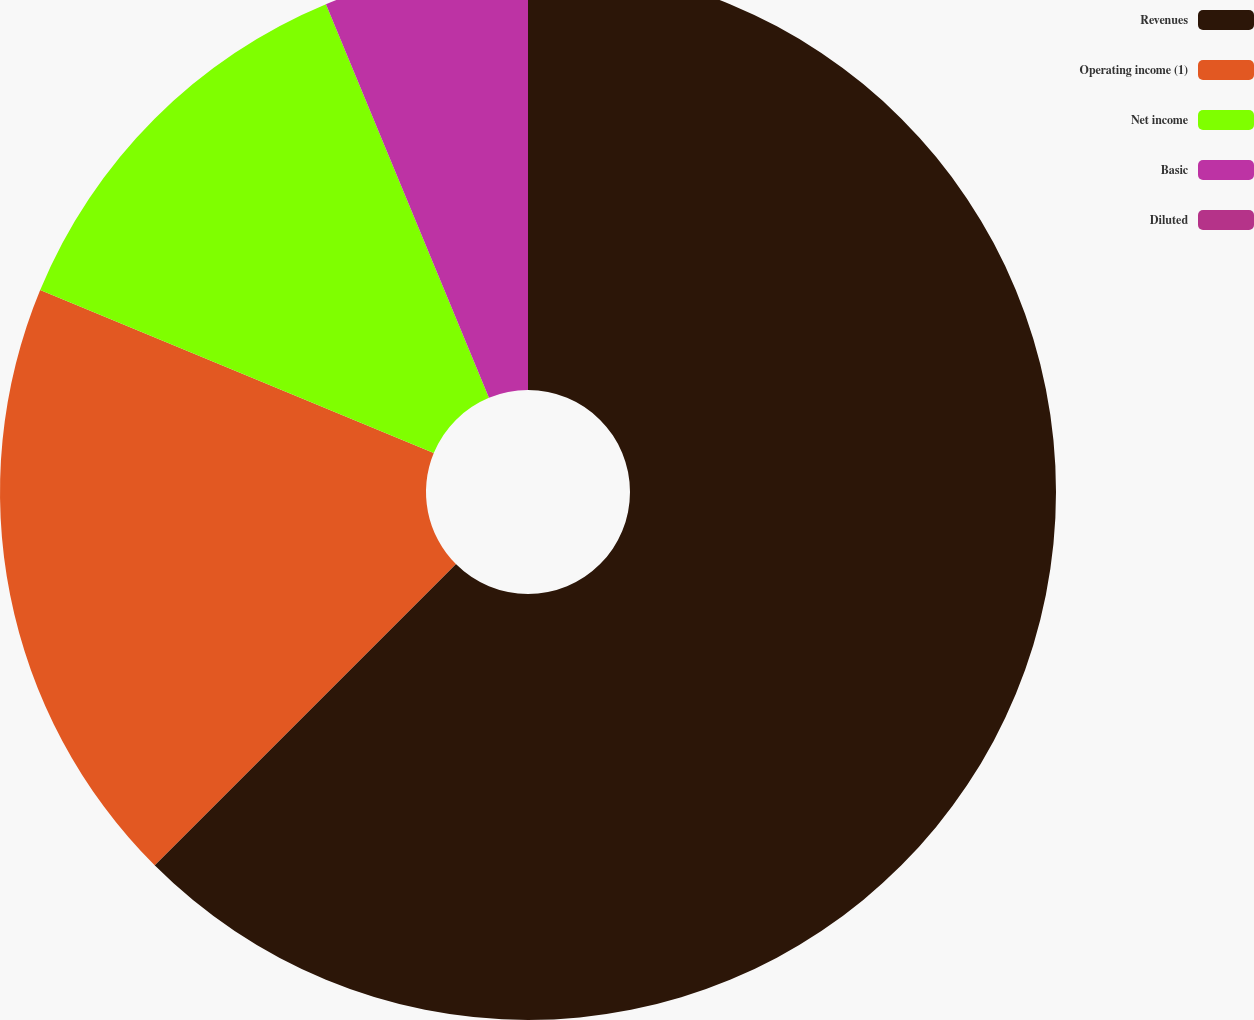<chart> <loc_0><loc_0><loc_500><loc_500><pie_chart><fcel>Revenues<fcel>Operating income (1)<fcel>Net income<fcel>Basic<fcel>Diluted<nl><fcel>62.5%<fcel>18.75%<fcel>12.5%<fcel>6.25%<fcel>0.0%<nl></chart> 